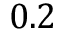<formula> <loc_0><loc_0><loc_500><loc_500>0 . 2</formula> 